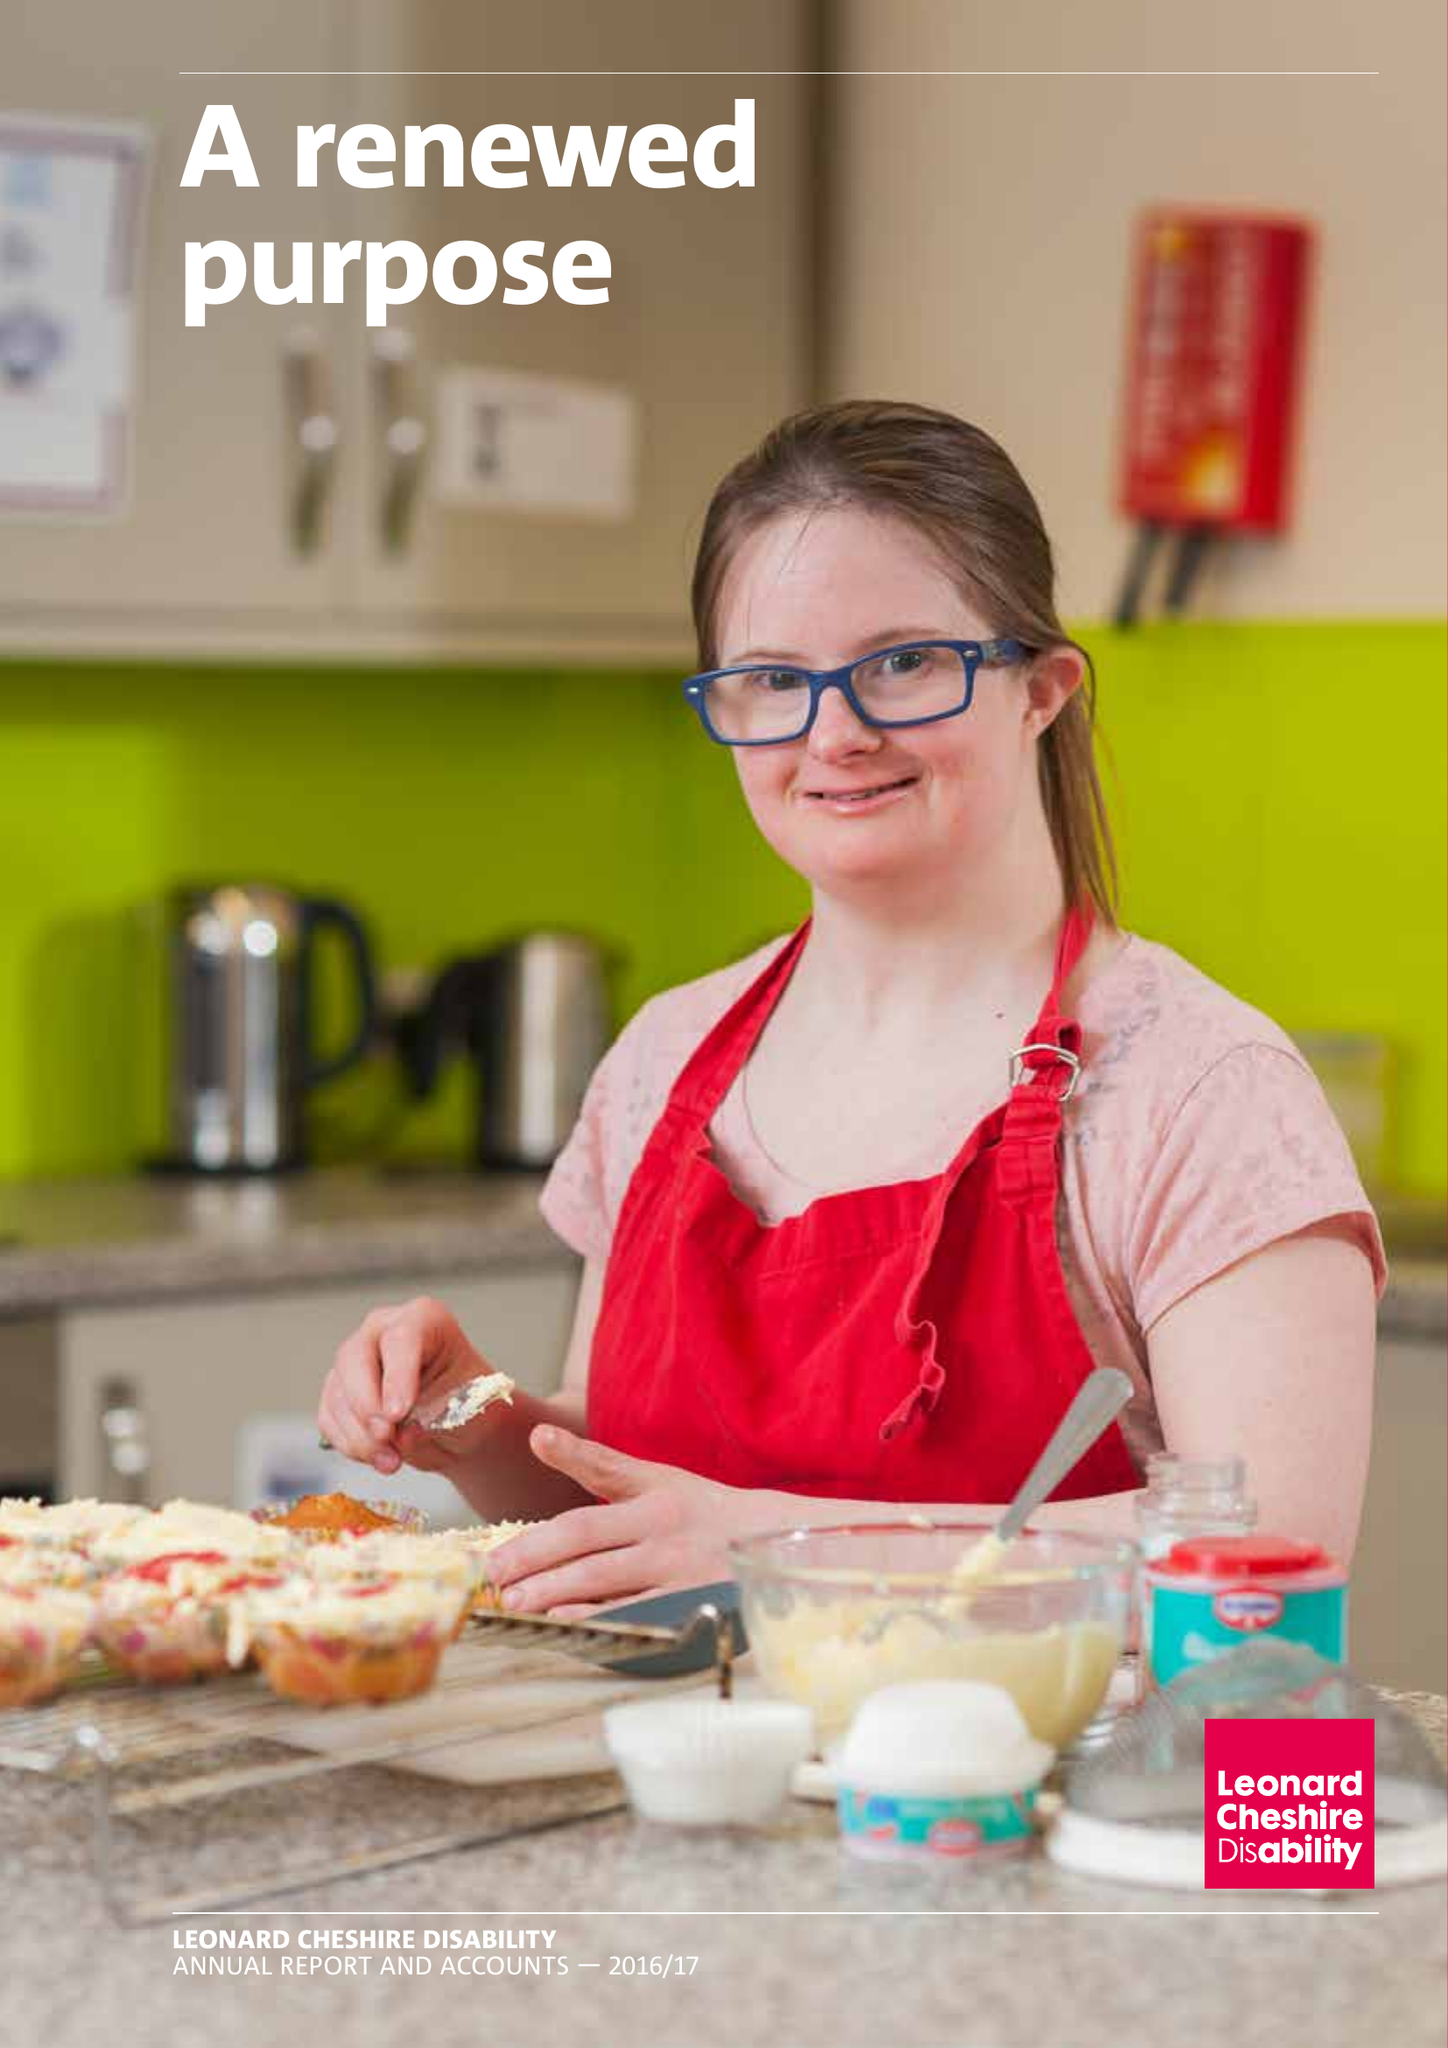What is the value for the charity_name?
Answer the question using a single word or phrase. Leonard Cheshire Disability 